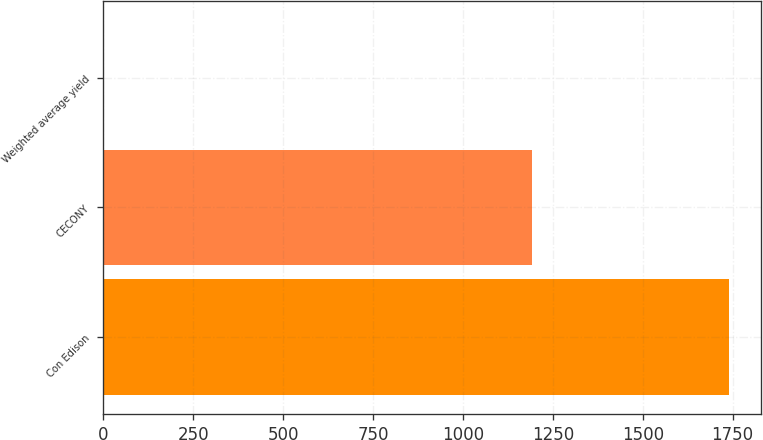Convert chart to OTSL. <chart><loc_0><loc_0><loc_500><loc_500><bar_chart><fcel>Con Edison<fcel>CECONY<fcel>Weighted average yield<nl><fcel>1741<fcel>1192<fcel>3<nl></chart> 